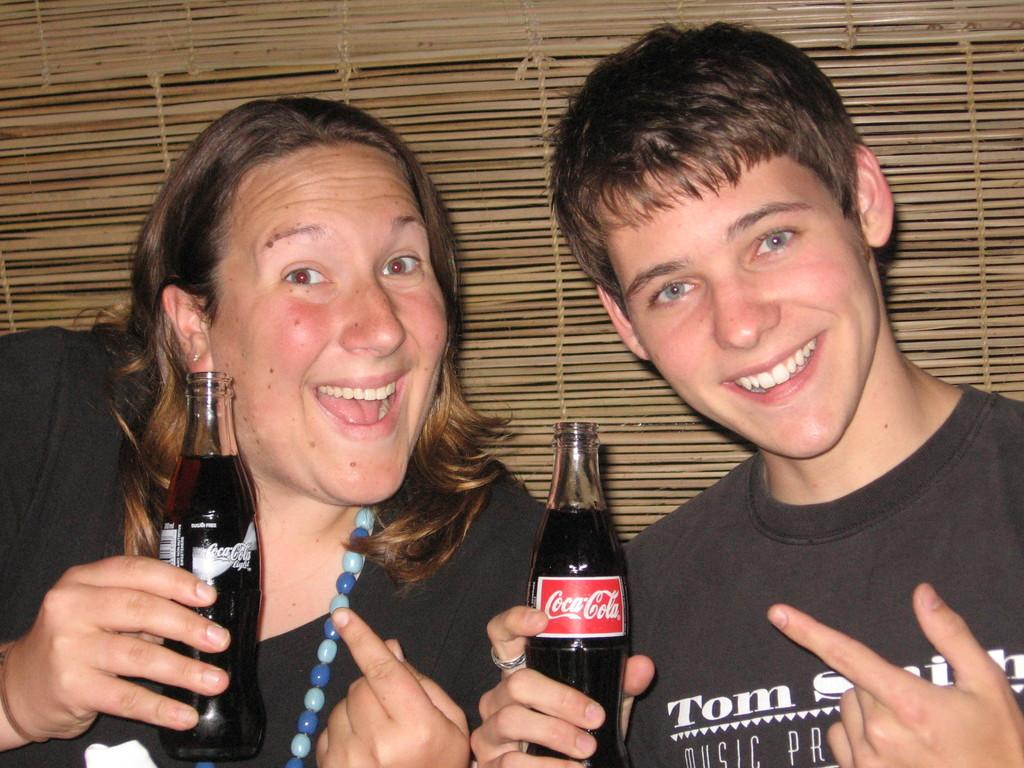Who is present in the image? There is a woman and a boy in the image. What are they holding in their hands? Both the woman and the boy are holding drink bottles. What is the facial expression of the people in the image? They are smiling. What can be seen in the background of the image? There is a wooden curtain in the background. What type of hate can be seen in the image? There is no hate present in the image; both the woman and the boy are smiling. What is the taste of the drink bottles they are holding? The taste of the drink bottles cannot be determined from the image. 